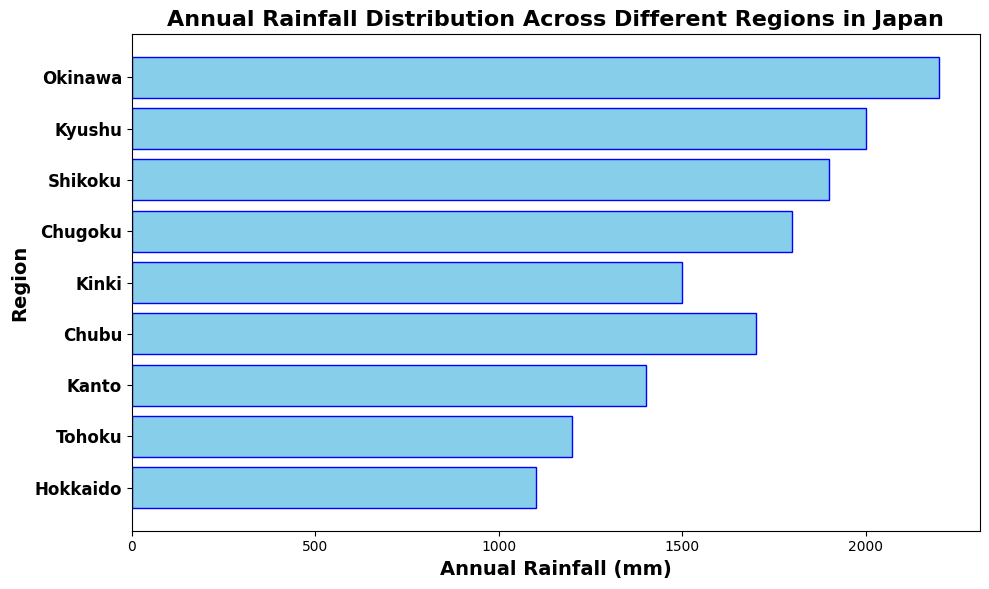Which region experiences the highest annual rainfall? The tallest bar in the horizontal bar chart represents the region with the highest annual rainfall. By visually comparing the length of all bars, Okinawa has the longest bar.
Answer: Okinawa Which region experiences less annual rainfall, Tohoku or Kinki? To compare the annual rainfall between Tohoku and Kinki, we look at the lengths of their respective bars. Tohoku's bar is shorter than Kinki's bar.
Answer: Tohoku What is the total annual rainfall for Hokkaido, Chubu, and Kyushu combined? Sum the annual rainfall values for Hokkaido (1100 mm), Chubu (1700 mm), and Kyushu (2000 mm). The total is 1100 + 1700 + 2000.
Answer: 4800 mm Which region has an annual rainfall difference of 500 mm from Kyushu? Kyushu has an annual rainfall of 2000 mm. To find a region with a 500 mm difference, we add and subtract 500 from 2000 (2000 + 500 = 2500 and 2000 - 500 = 1500). The annual rainfall that fits this criteria is 1500 mm, which is Kinki.
Answer: Kinki How many regions have an annual rainfall greater than 1500 mm? The regions with annual rainfall above 1500 mm are Chugoku (1800 mm), Shikoku (1900 mm), Kyushu (2000 mm), and Okinawa (2200 mm). Count these regions.
Answer: 4 Which region experiences 300 mm more rainfall than Tohoku? Tohoku has an annual rainfall of 1200 mm. Adding 300 mm gives 1500 mm. The region with 1500 mm rainfall is Kinki.
Answer: Kinki What is the average annual rainfall of the regions: Hokkaido, Kanto, and Okinawa? The annual rainfall values for these regions are Hokkaido (1100 mm), Kanto (1400 mm), and Okinawa (2200 mm). Sum these values and divide by 3 (i.e., (1100 + 1400 + 2200) / 3).
Answer: 1566.67 mm Which two regions have a combined annual rainfall closest to 2600 mm? We need to add the annual rainfall values of different region pairs until we find the pair that sums to 2600 mm. The pair Hokkaido (1100 mm) and Kanto (1400 mm) sums to 2500 mm, which is closest to 2600 mm.
Answer: Hokkaido and Kanto 